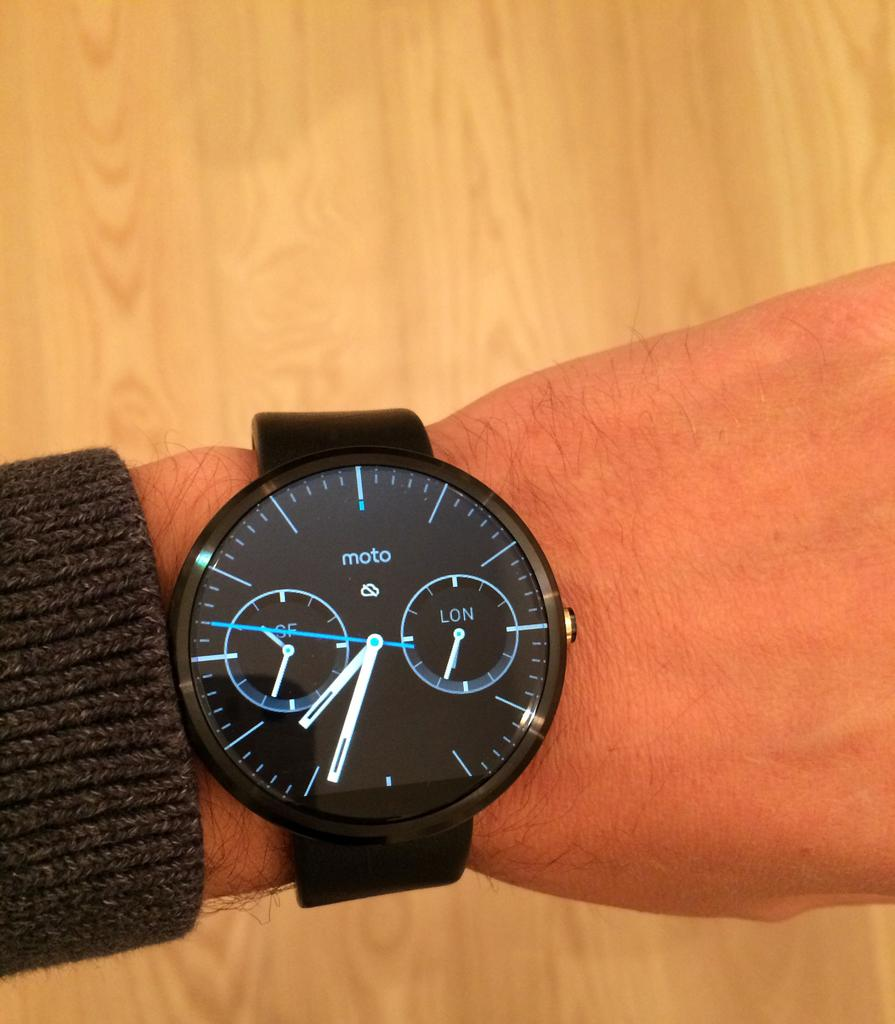What part of a person's body is visible in the image? There is a person's hand in the image. What is the hand holding or wearing? The hand is wearing a watch. What type of surface is at the bottom of the image? There is a wooden surface at the bottom of the image. What type of string is being used to mark the person's territory in the image? There is no string or territory present in the image; it only features a person's hand wearing a watch and a wooden surface. 